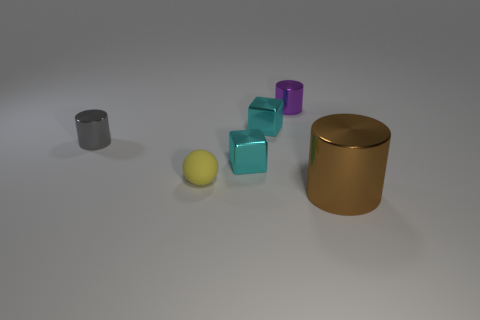Add 4 red metallic spheres. How many objects exist? 10 Subtract all cubes. How many objects are left? 4 Subtract 0 red balls. How many objects are left? 6 Subtract all tiny gray metallic cylinders. Subtract all yellow spheres. How many objects are left? 4 Add 4 gray things. How many gray things are left? 5 Add 1 small purple metal things. How many small purple metal things exist? 2 